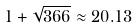<formula> <loc_0><loc_0><loc_500><loc_500>1 + \sqrt { 3 6 6 } \approx 2 0 . 1 3</formula> 